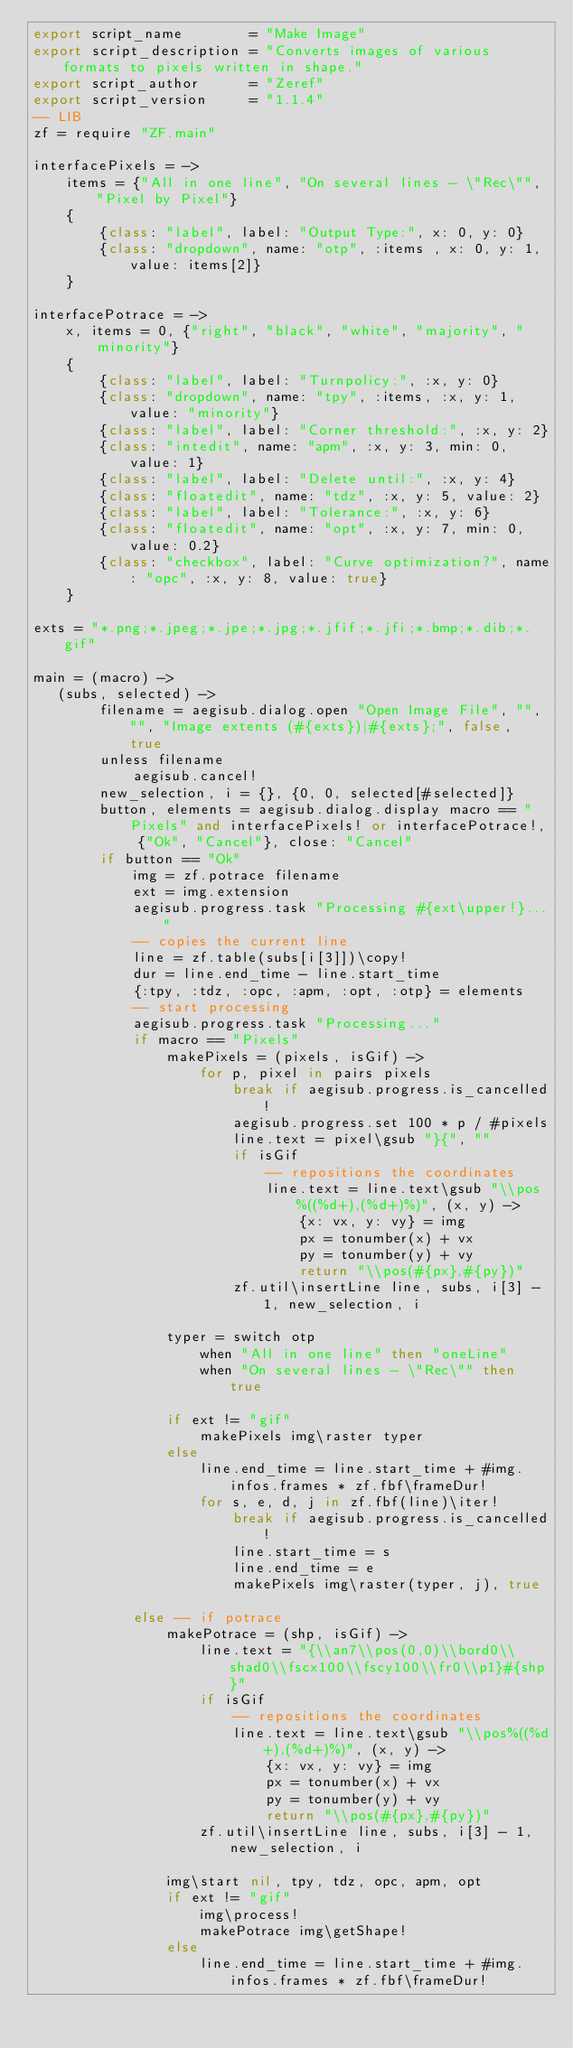Convert code to text. <code><loc_0><loc_0><loc_500><loc_500><_MoonScript_>export script_name        = "Make Image"
export script_description = "Converts images of various formats to pixels written in shape."
export script_author      = "Zeref"
export script_version     = "1.1.4"
-- LIB
zf = require "ZF.main"

interfacePixels = ->
    items = {"All in one line", "On several lines - \"Rec\"", "Pixel by Pixel"}
    {
        {class: "label", label: "Output Type:", x: 0, y: 0}
        {class: "dropdown", name: "otp", :items , x: 0, y: 1, value: items[2]}
    }

interfacePotrace = ->
    x, items = 0, {"right", "black", "white", "majority", "minority"}
    {
        {class: "label", label: "Turnpolicy:", :x, y: 0}
        {class: "dropdown", name: "tpy", :items, :x, y: 1, value: "minority"}
        {class: "label", label: "Corner threshold:", :x, y: 2}
        {class: "intedit", name: "apm", :x, y: 3, min: 0, value: 1}
        {class: "label", label: "Delete until:", :x, y: 4}
        {class: "floatedit", name: "tdz", :x, y: 5, value: 2}
        {class: "label", label: "Tolerance:", :x, y: 6}
        {class: "floatedit", name: "opt", :x, y: 7, min: 0, value: 0.2}
        {class: "checkbox", label: "Curve optimization?", name: "opc", :x, y: 8, value: true}
    }

exts = "*.png;*.jpeg;*.jpe;*.jpg;*.jfif;*.jfi;*.bmp;*.dib;*.gif"

main = (macro) ->
   (subs, selected) ->
        filename = aegisub.dialog.open "Open Image File", "", "", "Image extents (#{exts})|#{exts};", false, true
        unless filename
            aegisub.cancel!
        new_selection, i = {}, {0, 0, selected[#selected]}
        button, elements = aegisub.dialog.display macro == "Pixels" and interfacePixels! or interfacePotrace!, {"Ok", "Cancel"}, close: "Cancel"
        if button == "Ok"
            img = zf.potrace filename
            ext = img.extension
            aegisub.progress.task "Processing #{ext\upper!}..."
            -- copies the current line
            line = zf.table(subs[i[3]])\copy!
            dur = line.end_time - line.start_time
            {:tpy, :tdz, :opc, :apm, :opt, :otp} = elements
            -- start processing
            aegisub.progress.task "Processing..."
            if macro == "Pixels"
                makePixels = (pixels, isGif) ->
                    for p, pixel in pairs pixels
                        break if aegisub.progress.is_cancelled!
                        aegisub.progress.set 100 * p / #pixels
                        line.text = pixel\gsub "}{", ""
                        if isGif
                            -- repositions the coordinates
                            line.text = line.text\gsub "\\pos%((%d+),(%d+)%)", (x, y) ->
                                {x: vx, y: vy} = img
                                px = tonumber(x) + vx
                                py = tonumber(y) + vy
                                return "\\pos(#{px},#{py})"
                        zf.util\insertLine line, subs, i[3] - 1, new_selection, i

                typer = switch otp
                    when "All in one line" then "oneLine"
                    when "On several lines - \"Rec\"" then true

                if ext != "gif"
                    makePixels img\raster typer
                else
                    line.end_time = line.start_time + #img.infos.frames * zf.fbf\frameDur!
                    for s, e, d, j in zf.fbf(line)\iter!
                        break if aegisub.progress.is_cancelled!
                        line.start_time = s
                        line.end_time = e
                        makePixels img\raster(typer, j), true

            else -- if potrace
                makePotrace = (shp, isGif) ->
                    line.text = "{\\an7\\pos(0,0)\\bord0\\shad0\\fscx100\\fscy100\\fr0\\p1}#{shp}"
                    if isGif
                        -- repositions the coordinates
                        line.text = line.text\gsub "\\pos%((%d+),(%d+)%)", (x, y) ->
                            {x: vx, y: vy} = img
                            px = tonumber(x) + vx
                            py = tonumber(y) + vy
                            return "\\pos(#{px},#{py})"
                    zf.util\insertLine line, subs, i[3] - 1, new_selection, i

                img\start nil, tpy, tdz, opc, apm, opt
                if ext != "gif"
                    img\process!
                    makePotrace img\getShape!
                else
                    line.end_time = line.start_time + #img.infos.frames * zf.fbf\frameDur!</code> 